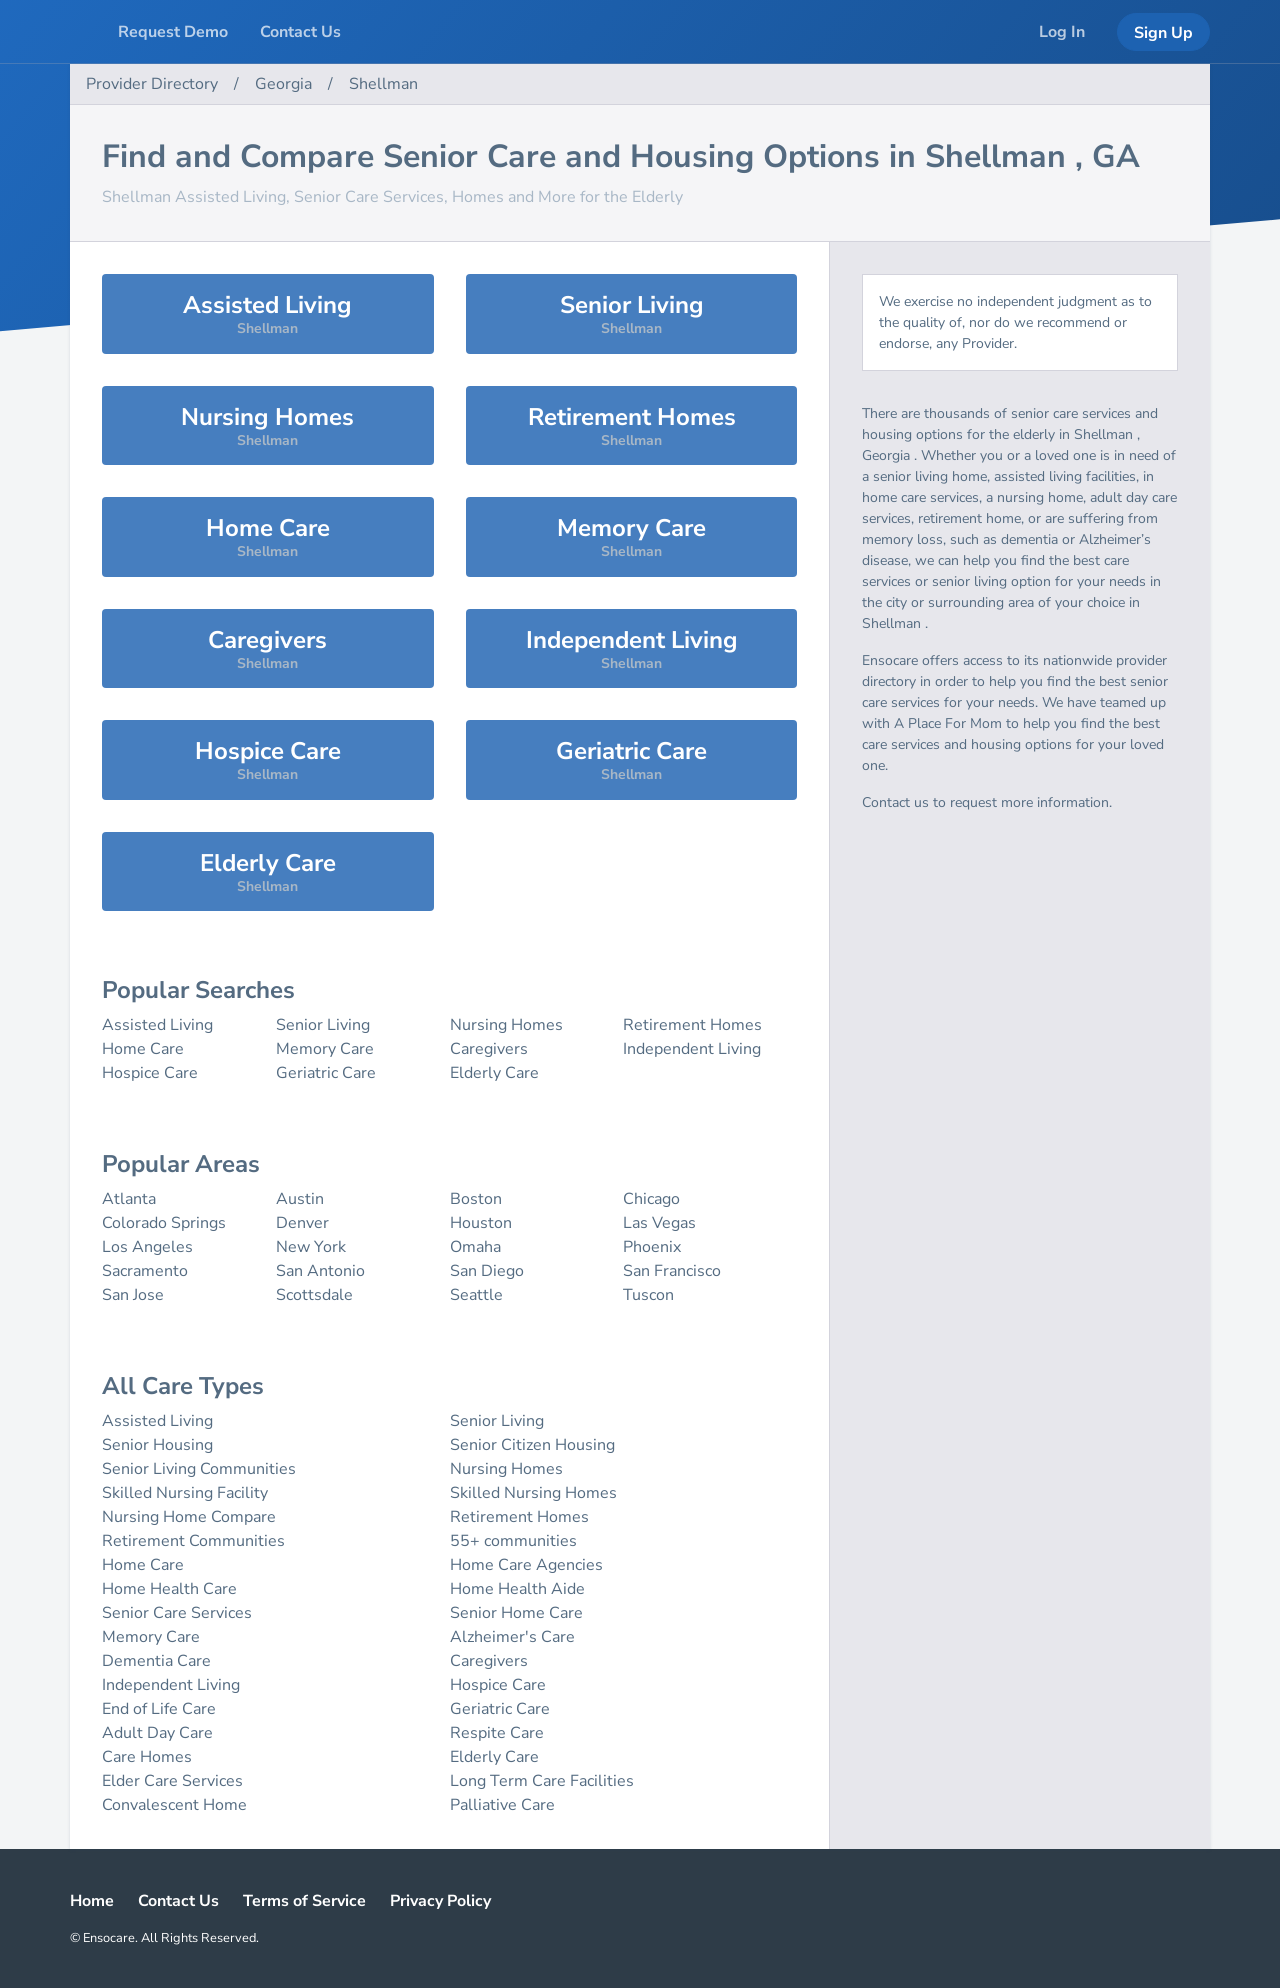Could you explain the services listed under 'Memory Care' in more detail? Certainly! 'Memory Care' refers to specialized care catered to individuals with memory issues, such as Alzheimer's or dementia. Facilities offering this kind of care are designed to provide a safe environment with routines to lower stress for people with memory loss. They offer services like structured activities, secured areas to prevent wandering, and staff trained specifically to care for those with cognitive impairment. 